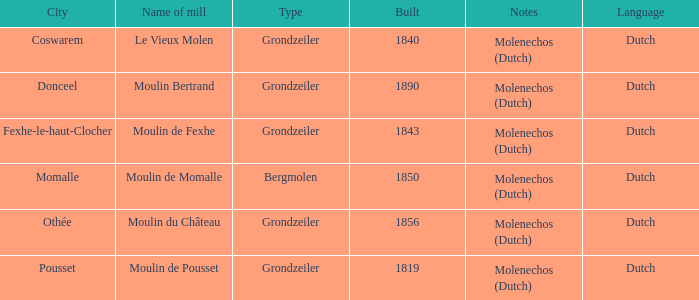What is year Built of the Moulin de Momalle Mill? 1850.0. 